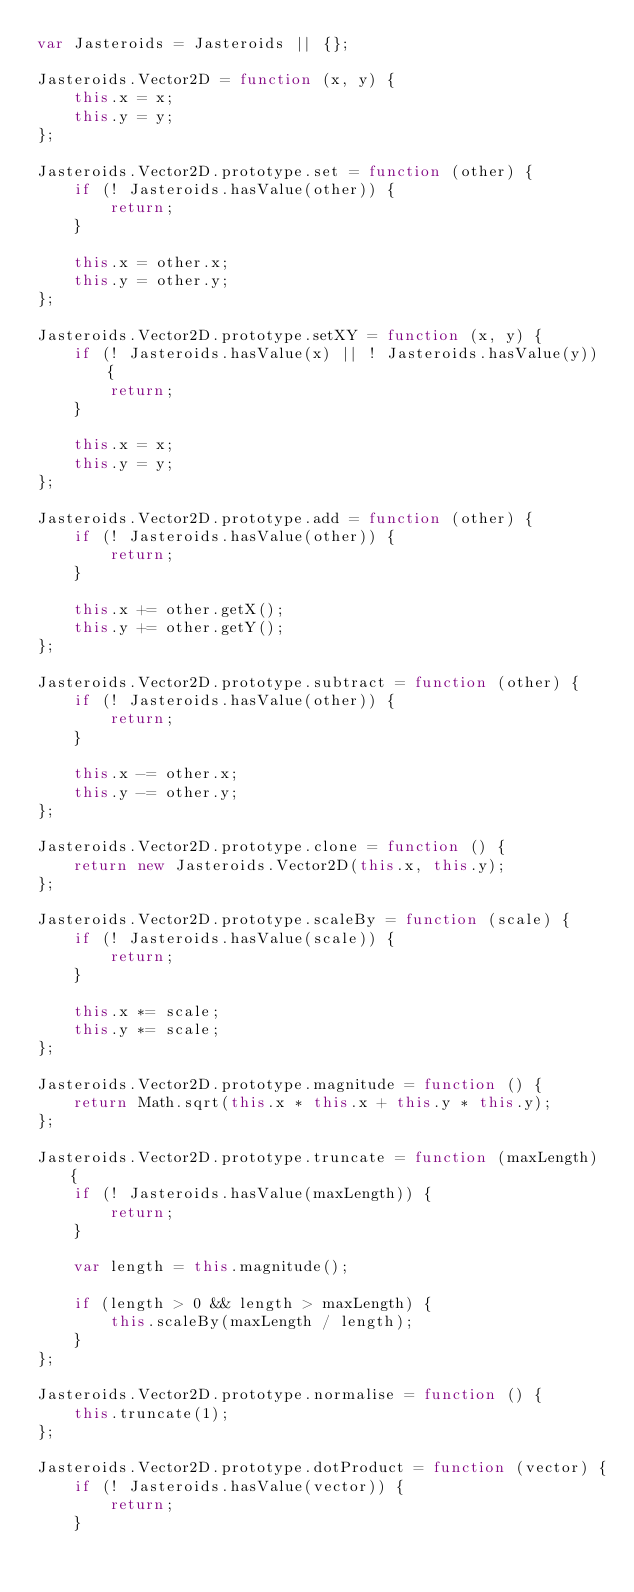Convert code to text. <code><loc_0><loc_0><loc_500><loc_500><_JavaScript_>var Jasteroids = Jasteroids || {};

Jasteroids.Vector2D = function (x, y) {
    this.x = x;
    this.y = y;
};

Jasteroids.Vector2D.prototype.set = function (other) {
    if (! Jasteroids.hasValue(other)) {
        return;
    }

    this.x = other.x;
    this.y = other.y;
};

Jasteroids.Vector2D.prototype.setXY = function (x, y) {
    if (! Jasteroids.hasValue(x) || ! Jasteroids.hasValue(y)) {
        return;
    }

    this.x = x;
    this.y = y;
};

Jasteroids.Vector2D.prototype.add = function (other) {
    if (! Jasteroids.hasValue(other)) {
        return;
    }

    this.x += other.getX();
    this.y += other.getY();
};

Jasteroids.Vector2D.prototype.subtract = function (other) {
    if (! Jasteroids.hasValue(other)) {
        return;
    }

    this.x -= other.x;
    this.y -= other.y;
};

Jasteroids.Vector2D.prototype.clone = function () {
    return new Jasteroids.Vector2D(this.x, this.y);
};

Jasteroids.Vector2D.prototype.scaleBy = function (scale) {
    if (! Jasteroids.hasValue(scale)) {
        return;
    }

    this.x *= scale;
    this.y *= scale;
};

Jasteroids.Vector2D.prototype.magnitude = function () {
    return Math.sqrt(this.x * this.x + this.y * this.y);
};

Jasteroids.Vector2D.prototype.truncate = function (maxLength) {
    if (! Jasteroids.hasValue(maxLength)) {
        return;
    }

    var length = this.magnitude();

    if (length > 0 && length > maxLength) {
        this.scaleBy(maxLength / length);
    }
};

Jasteroids.Vector2D.prototype.normalise = function () {
    this.truncate(1);
};

Jasteroids.Vector2D.prototype.dotProduct = function (vector) {
    if (! Jasteroids.hasValue(vector)) {
        return;
    }
</code> 